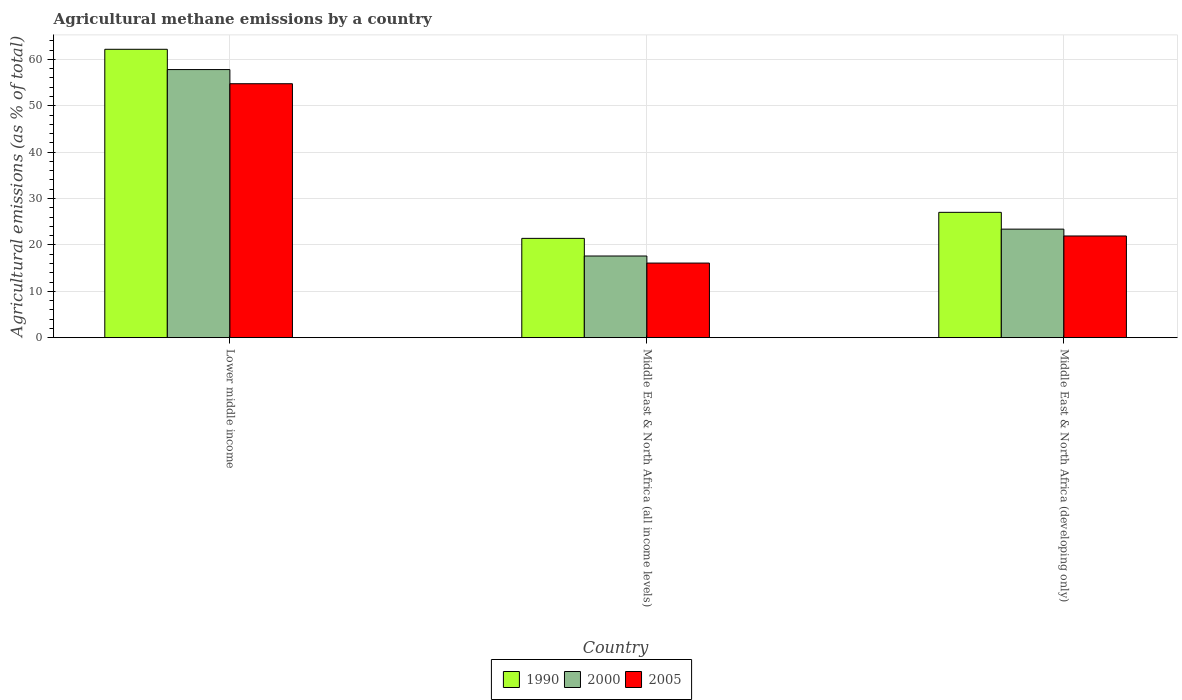How many different coloured bars are there?
Your answer should be compact. 3. Are the number of bars on each tick of the X-axis equal?
Make the answer very short. Yes. How many bars are there on the 1st tick from the left?
Give a very brief answer. 3. What is the label of the 3rd group of bars from the left?
Ensure brevity in your answer.  Middle East & North Africa (developing only). In how many cases, is the number of bars for a given country not equal to the number of legend labels?
Your response must be concise. 0. What is the amount of agricultural methane emitted in 2005 in Lower middle income?
Your response must be concise. 54.76. Across all countries, what is the maximum amount of agricultural methane emitted in 2005?
Your answer should be very brief. 54.76. Across all countries, what is the minimum amount of agricultural methane emitted in 1990?
Your response must be concise. 21.41. In which country was the amount of agricultural methane emitted in 2005 maximum?
Make the answer very short. Lower middle income. In which country was the amount of agricultural methane emitted in 1990 minimum?
Make the answer very short. Middle East & North Africa (all income levels). What is the total amount of agricultural methane emitted in 2000 in the graph?
Offer a terse response. 98.83. What is the difference between the amount of agricultural methane emitted in 1990 in Lower middle income and that in Middle East & North Africa (developing only)?
Your response must be concise. 35.16. What is the difference between the amount of agricultural methane emitted in 2000 in Lower middle income and the amount of agricultural methane emitted in 1990 in Middle East & North Africa (developing only)?
Offer a very short reply. 30.79. What is the average amount of agricultural methane emitted in 1990 per country?
Your answer should be compact. 36.87. What is the difference between the amount of agricultural methane emitted of/in 2005 and amount of agricultural methane emitted of/in 2000 in Middle East & North Africa (all income levels)?
Offer a very short reply. -1.52. In how many countries, is the amount of agricultural methane emitted in 2005 greater than 60 %?
Your answer should be very brief. 0. What is the ratio of the amount of agricultural methane emitted in 1990 in Lower middle income to that in Middle East & North Africa (developing only)?
Provide a short and direct response. 2.3. Is the difference between the amount of agricultural methane emitted in 2005 in Middle East & North Africa (all income levels) and Middle East & North Africa (developing only) greater than the difference between the amount of agricultural methane emitted in 2000 in Middle East & North Africa (all income levels) and Middle East & North Africa (developing only)?
Ensure brevity in your answer.  No. What is the difference between the highest and the second highest amount of agricultural methane emitted in 2005?
Your answer should be very brief. -5.84. What is the difference between the highest and the lowest amount of agricultural methane emitted in 1990?
Give a very brief answer. 40.77. Are all the bars in the graph horizontal?
Provide a short and direct response. No. How many legend labels are there?
Provide a succinct answer. 3. What is the title of the graph?
Your response must be concise. Agricultural methane emissions by a country. Does "1979" appear as one of the legend labels in the graph?
Make the answer very short. No. What is the label or title of the Y-axis?
Make the answer very short. Agricultural emissions (as % of total). What is the Agricultural emissions (as % of total) in 1990 in Lower middle income?
Your response must be concise. 62.18. What is the Agricultural emissions (as % of total) of 2000 in Lower middle income?
Make the answer very short. 57.81. What is the Agricultural emissions (as % of total) in 2005 in Lower middle income?
Your answer should be compact. 54.76. What is the Agricultural emissions (as % of total) in 1990 in Middle East & North Africa (all income levels)?
Keep it short and to the point. 21.41. What is the Agricultural emissions (as % of total) of 2000 in Middle East & North Africa (all income levels)?
Provide a succinct answer. 17.61. What is the Agricultural emissions (as % of total) of 2005 in Middle East & North Africa (all income levels)?
Give a very brief answer. 16.09. What is the Agricultural emissions (as % of total) of 1990 in Middle East & North Africa (developing only)?
Give a very brief answer. 27.03. What is the Agricultural emissions (as % of total) in 2000 in Middle East & North Africa (developing only)?
Your answer should be very brief. 23.4. What is the Agricultural emissions (as % of total) of 2005 in Middle East & North Africa (developing only)?
Offer a very short reply. 21.93. Across all countries, what is the maximum Agricultural emissions (as % of total) of 1990?
Ensure brevity in your answer.  62.18. Across all countries, what is the maximum Agricultural emissions (as % of total) in 2000?
Your response must be concise. 57.81. Across all countries, what is the maximum Agricultural emissions (as % of total) of 2005?
Your answer should be compact. 54.76. Across all countries, what is the minimum Agricultural emissions (as % of total) of 1990?
Your response must be concise. 21.41. Across all countries, what is the minimum Agricultural emissions (as % of total) of 2000?
Keep it short and to the point. 17.61. Across all countries, what is the minimum Agricultural emissions (as % of total) in 2005?
Make the answer very short. 16.09. What is the total Agricultural emissions (as % of total) of 1990 in the graph?
Keep it short and to the point. 110.62. What is the total Agricultural emissions (as % of total) of 2000 in the graph?
Give a very brief answer. 98.83. What is the total Agricultural emissions (as % of total) of 2005 in the graph?
Provide a short and direct response. 92.77. What is the difference between the Agricultural emissions (as % of total) of 1990 in Lower middle income and that in Middle East & North Africa (all income levels)?
Provide a succinct answer. 40.77. What is the difference between the Agricultural emissions (as % of total) of 2000 in Lower middle income and that in Middle East & North Africa (all income levels)?
Offer a terse response. 40.2. What is the difference between the Agricultural emissions (as % of total) in 2005 in Lower middle income and that in Middle East & North Africa (all income levels)?
Provide a succinct answer. 38.67. What is the difference between the Agricultural emissions (as % of total) of 1990 in Lower middle income and that in Middle East & North Africa (developing only)?
Offer a very short reply. 35.16. What is the difference between the Agricultural emissions (as % of total) in 2000 in Lower middle income and that in Middle East & North Africa (developing only)?
Make the answer very short. 34.41. What is the difference between the Agricultural emissions (as % of total) in 2005 in Lower middle income and that in Middle East & North Africa (developing only)?
Ensure brevity in your answer.  32.83. What is the difference between the Agricultural emissions (as % of total) in 1990 in Middle East & North Africa (all income levels) and that in Middle East & North Africa (developing only)?
Offer a very short reply. -5.61. What is the difference between the Agricultural emissions (as % of total) of 2000 in Middle East & North Africa (all income levels) and that in Middle East & North Africa (developing only)?
Provide a short and direct response. -5.8. What is the difference between the Agricultural emissions (as % of total) in 2005 in Middle East & North Africa (all income levels) and that in Middle East & North Africa (developing only)?
Ensure brevity in your answer.  -5.84. What is the difference between the Agricultural emissions (as % of total) in 1990 in Lower middle income and the Agricultural emissions (as % of total) in 2000 in Middle East & North Africa (all income levels)?
Provide a short and direct response. 44.58. What is the difference between the Agricultural emissions (as % of total) in 1990 in Lower middle income and the Agricultural emissions (as % of total) in 2005 in Middle East & North Africa (all income levels)?
Provide a succinct answer. 46.1. What is the difference between the Agricultural emissions (as % of total) of 2000 in Lower middle income and the Agricultural emissions (as % of total) of 2005 in Middle East & North Africa (all income levels)?
Offer a terse response. 41.73. What is the difference between the Agricultural emissions (as % of total) in 1990 in Lower middle income and the Agricultural emissions (as % of total) in 2000 in Middle East & North Africa (developing only)?
Your answer should be compact. 38.78. What is the difference between the Agricultural emissions (as % of total) of 1990 in Lower middle income and the Agricultural emissions (as % of total) of 2005 in Middle East & North Africa (developing only)?
Provide a short and direct response. 40.26. What is the difference between the Agricultural emissions (as % of total) of 2000 in Lower middle income and the Agricultural emissions (as % of total) of 2005 in Middle East & North Africa (developing only)?
Offer a very short reply. 35.89. What is the difference between the Agricultural emissions (as % of total) in 1990 in Middle East & North Africa (all income levels) and the Agricultural emissions (as % of total) in 2000 in Middle East & North Africa (developing only)?
Your answer should be very brief. -1.99. What is the difference between the Agricultural emissions (as % of total) in 1990 in Middle East & North Africa (all income levels) and the Agricultural emissions (as % of total) in 2005 in Middle East & North Africa (developing only)?
Provide a succinct answer. -0.51. What is the difference between the Agricultural emissions (as % of total) in 2000 in Middle East & North Africa (all income levels) and the Agricultural emissions (as % of total) in 2005 in Middle East & North Africa (developing only)?
Give a very brief answer. -4.32. What is the average Agricultural emissions (as % of total) of 1990 per country?
Your response must be concise. 36.87. What is the average Agricultural emissions (as % of total) in 2000 per country?
Offer a very short reply. 32.94. What is the average Agricultural emissions (as % of total) in 2005 per country?
Your answer should be very brief. 30.92. What is the difference between the Agricultural emissions (as % of total) of 1990 and Agricultural emissions (as % of total) of 2000 in Lower middle income?
Your response must be concise. 4.37. What is the difference between the Agricultural emissions (as % of total) of 1990 and Agricultural emissions (as % of total) of 2005 in Lower middle income?
Your response must be concise. 7.42. What is the difference between the Agricultural emissions (as % of total) in 2000 and Agricultural emissions (as % of total) in 2005 in Lower middle income?
Your answer should be very brief. 3.05. What is the difference between the Agricultural emissions (as % of total) of 1990 and Agricultural emissions (as % of total) of 2000 in Middle East & North Africa (all income levels)?
Offer a terse response. 3.81. What is the difference between the Agricultural emissions (as % of total) in 1990 and Agricultural emissions (as % of total) in 2005 in Middle East & North Africa (all income levels)?
Make the answer very short. 5.33. What is the difference between the Agricultural emissions (as % of total) in 2000 and Agricultural emissions (as % of total) in 2005 in Middle East & North Africa (all income levels)?
Provide a short and direct response. 1.52. What is the difference between the Agricultural emissions (as % of total) in 1990 and Agricultural emissions (as % of total) in 2000 in Middle East & North Africa (developing only)?
Provide a short and direct response. 3.62. What is the difference between the Agricultural emissions (as % of total) of 1990 and Agricultural emissions (as % of total) of 2005 in Middle East & North Africa (developing only)?
Give a very brief answer. 5.1. What is the difference between the Agricultural emissions (as % of total) in 2000 and Agricultural emissions (as % of total) in 2005 in Middle East & North Africa (developing only)?
Provide a short and direct response. 1.48. What is the ratio of the Agricultural emissions (as % of total) in 1990 in Lower middle income to that in Middle East & North Africa (all income levels)?
Your response must be concise. 2.9. What is the ratio of the Agricultural emissions (as % of total) of 2000 in Lower middle income to that in Middle East & North Africa (all income levels)?
Give a very brief answer. 3.28. What is the ratio of the Agricultural emissions (as % of total) in 2005 in Lower middle income to that in Middle East & North Africa (all income levels)?
Provide a short and direct response. 3.4. What is the ratio of the Agricultural emissions (as % of total) in 1990 in Lower middle income to that in Middle East & North Africa (developing only)?
Keep it short and to the point. 2.3. What is the ratio of the Agricultural emissions (as % of total) in 2000 in Lower middle income to that in Middle East & North Africa (developing only)?
Offer a terse response. 2.47. What is the ratio of the Agricultural emissions (as % of total) in 2005 in Lower middle income to that in Middle East & North Africa (developing only)?
Make the answer very short. 2.5. What is the ratio of the Agricultural emissions (as % of total) of 1990 in Middle East & North Africa (all income levels) to that in Middle East & North Africa (developing only)?
Provide a succinct answer. 0.79. What is the ratio of the Agricultural emissions (as % of total) of 2000 in Middle East & North Africa (all income levels) to that in Middle East & North Africa (developing only)?
Offer a very short reply. 0.75. What is the ratio of the Agricultural emissions (as % of total) in 2005 in Middle East & North Africa (all income levels) to that in Middle East & North Africa (developing only)?
Keep it short and to the point. 0.73. What is the difference between the highest and the second highest Agricultural emissions (as % of total) of 1990?
Offer a very short reply. 35.16. What is the difference between the highest and the second highest Agricultural emissions (as % of total) in 2000?
Give a very brief answer. 34.41. What is the difference between the highest and the second highest Agricultural emissions (as % of total) of 2005?
Provide a succinct answer. 32.83. What is the difference between the highest and the lowest Agricultural emissions (as % of total) in 1990?
Keep it short and to the point. 40.77. What is the difference between the highest and the lowest Agricultural emissions (as % of total) of 2000?
Your response must be concise. 40.2. What is the difference between the highest and the lowest Agricultural emissions (as % of total) in 2005?
Offer a very short reply. 38.67. 